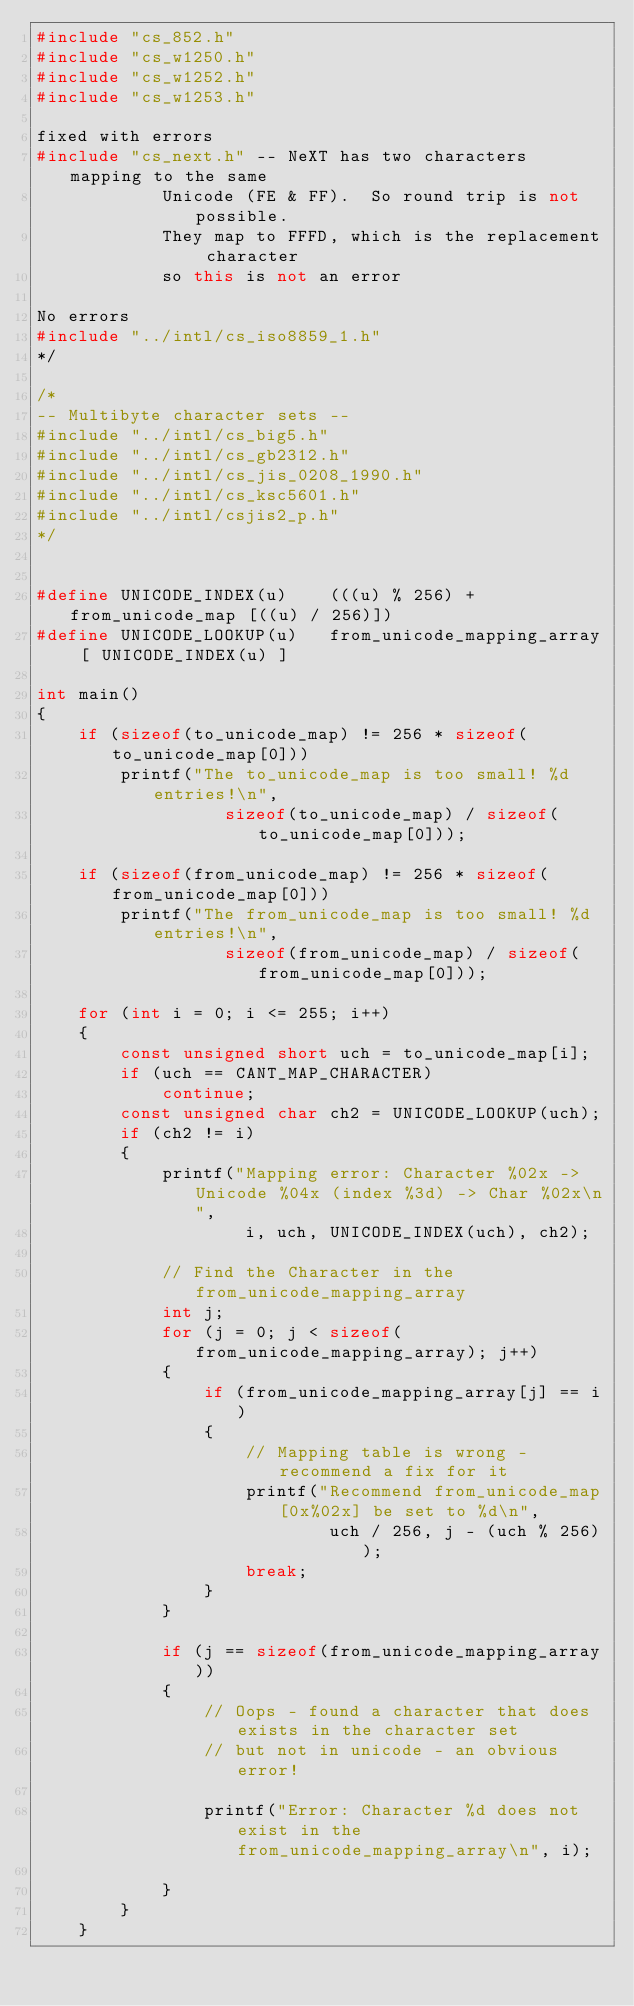Convert code to text. <code><loc_0><loc_0><loc_500><loc_500><_C++_>#include "cs_852.h"
#include "cs_w1250.h"
#include "cs_w1252.h"
#include "cs_w1253.h"

fixed with errors
#include "cs_next.h" -- NeXT has two characters mapping to the same
			Unicode (FE & FF).  So round trip is not possible.
			They map to FFFD, which is the replacement character
			so this is not an error

No errors
#include "../intl/cs_iso8859_1.h"
*/

/*
-- Multibyte character sets --
#include "../intl/cs_big5.h"
#include "../intl/cs_gb2312.h"
#include "../intl/cs_jis_0208_1990.h"
#include "../intl/cs_ksc5601.h"
#include "../intl/csjis2_p.h"
*/


#define UNICODE_INDEX(u)	(((u) % 256) + from_unicode_map [((u) / 256)])
#define UNICODE_LOOKUP(u)	from_unicode_mapping_array [ UNICODE_INDEX(u) ]

int main()
{
	if (sizeof(to_unicode_map) != 256 * sizeof(to_unicode_map[0]))
		printf("The to_unicode_map is too small! %d entries!\n",
				  sizeof(to_unicode_map) / sizeof(to_unicode_map[0]));

	if (sizeof(from_unicode_map) != 256 * sizeof(from_unicode_map[0]))
		printf("The from_unicode_map is too small! %d entries!\n",
				  sizeof(from_unicode_map) / sizeof(from_unicode_map[0]));

	for (int i = 0; i <= 255; i++)
	{
		const unsigned short uch = to_unicode_map[i];
		if (uch == CANT_MAP_CHARACTER)
			continue;
		const unsigned char ch2 = UNICODE_LOOKUP(uch);
		if (ch2 != i)
		{
			printf("Mapping error: Character %02x -> Unicode %04x (index %3d) -> Char %02x\n",
					i, uch, UNICODE_INDEX(uch), ch2);

			// Find the Character in the from_unicode_mapping_array
			int j;
			for (j = 0; j < sizeof(from_unicode_mapping_array); j++)
			{
				if (from_unicode_mapping_array[j] == i)
				{
					// Mapping table is wrong - recommend a fix for it
					printf("Recommend from_unicode_map[0x%02x] be set to %d\n",
							uch / 256, j - (uch % 256));
					break;
				}
			}

			if (j == sizeof(from_unicode_mapping_array))
			{
				// Oops - found a character that does exists in the character set
				// but not in unicode - an obvious error!

				printf("Error: Character %d does not exist in the from_unicode_mapping_array\n", i);

			}
		}
	}
</code> 